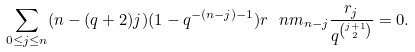Convert formula to latex. <formula><loc_0><loc_0><loc_500><loc_500>\sum _ { 0 \leq j \leq n } ( n - ( q + 2 ) j ) ( 1 - q ^ { - ( n - j ) - 1 } ) r \ n m _ { n - j } \frac { r _ { j } } { q ^ { \binom { j + 1 } { 2 } } } = 0 .</formula> 